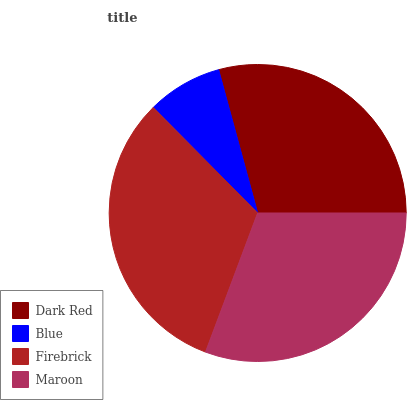Is Blue the minimum?
Answer yes or no. Yes. Is Firebrick the maximum?
Answer yes or no. Yes. Is Firebrick the minimum?
Answer yes or no. No. Is Blue the maximum?
Answer yes or no. No. Is Firebrick greater than Blue?
Answer yes or no. Yes. Is Blue less than Firebrick?
Answer yes or no. Yes. Is Blue greater than Firebrick?
Answer yes or no. No. Is Firebrick less than Blue?
Answer yes or no. No. Is Maroon the high median?
Answer yes or no. Yes. Is Dark Red the low median?
Answer yes or no. Yes. Is Dark Red the high median?
Answer yes or no. No. Is Blue the low median?
Answer yes or no. No. 